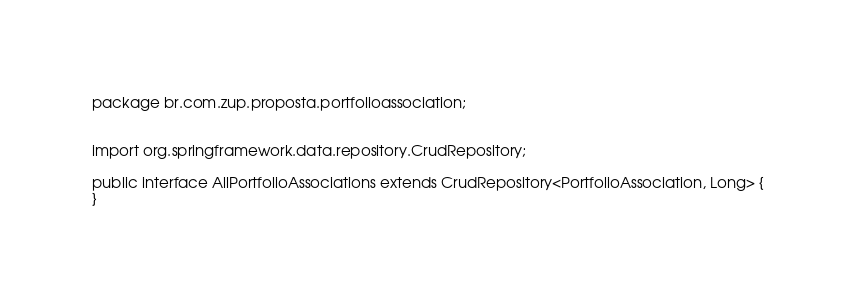<code> <loc_0><loc_0><loc_500><loc_500><_Java_>package br.com.zup.proposta.portfolioassociation;


import org.springframework.data.repository.CrudRepository;

public interface AllPortfolioAssociations extends CrudRepository<PortfolioAssociation, Long> {
}
</code> 